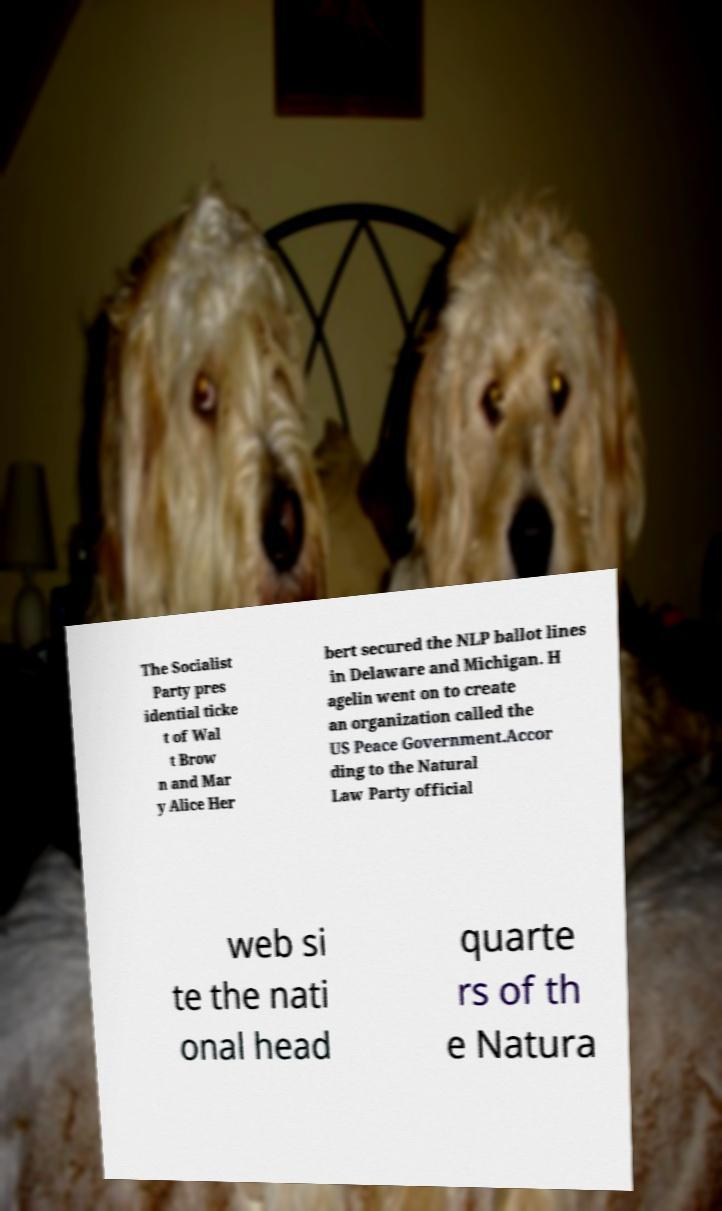What messages or text are displayed in this image? I need them in a readable, typed format. The Socialist Party pres idential ticke t of Wal t Brow n and Mar y Alice Her bert secured the NLP ballot lines in Delaware and Michigan. H agelin went on to create an organization called the US Peace Government.Accor ding to the Natural Law Party official web si te the nati onal head quarte rs of th e Natura 